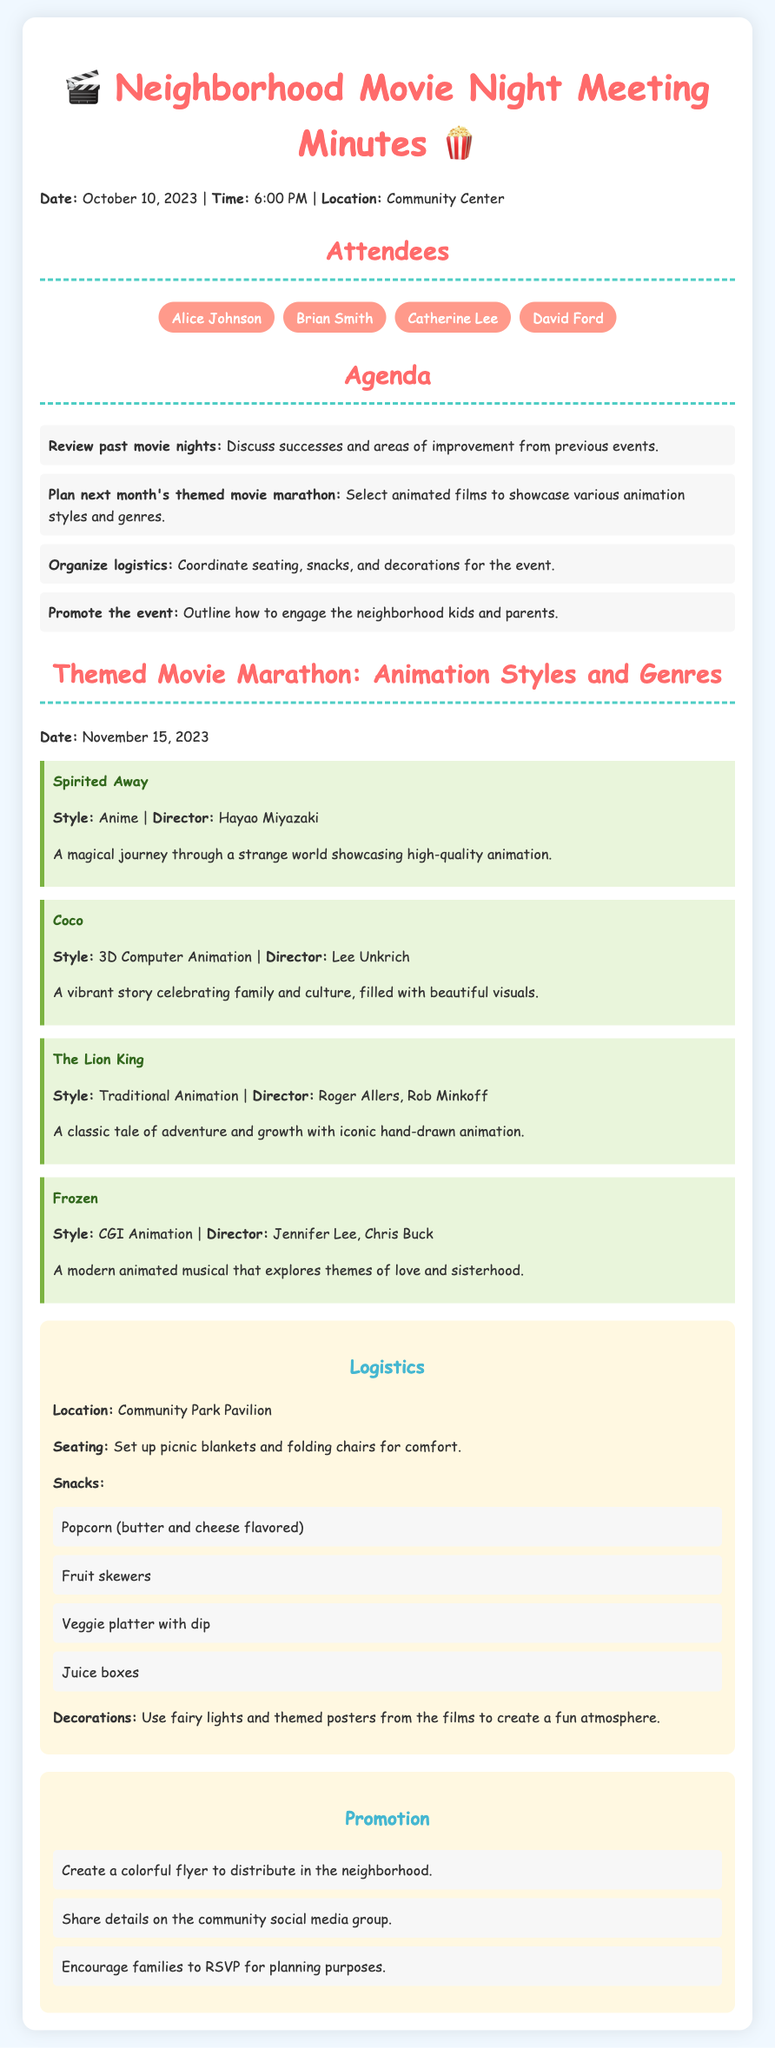What is the date of the movie marathon? The document states that the themed movie marathon is scheduled for November 15, 2023.
Answer: November 15, 2023 Who directed "Spirited Away"? The director of "Spirited Away" mentioned in the document is Hayao Miyazaki.
Answer: Hayao Miyazaki What is one of the snacks listed for the event? The document lists popcorn (butter and cheese flavored) as one of the snacks for the event.
Answer: Popcorn What type of decorations will be used? The document mentions that fairy lights and themed posters from the films will be used as decorations.
Answer: Fairy lights and themed posters How many attendees were present at the meeting? The names of four attendees are listed in the document, indicating there were four attendees.
Answer: Four Which animation style is used in "Coco"? The document specifies that "Coco" uses 3D Computer Animation as its style.
Answer: 3D Computer Animation What is the main theme of the movie "Frozen"? The document states that "Frozen" explores themes of love and sisterhood.
Answer: Love and sisterhood What is the location of the movie marathon? According to the document, the movie marathon will be held at the Community Park Pavilion.
Answer: Community Park Pavilion 